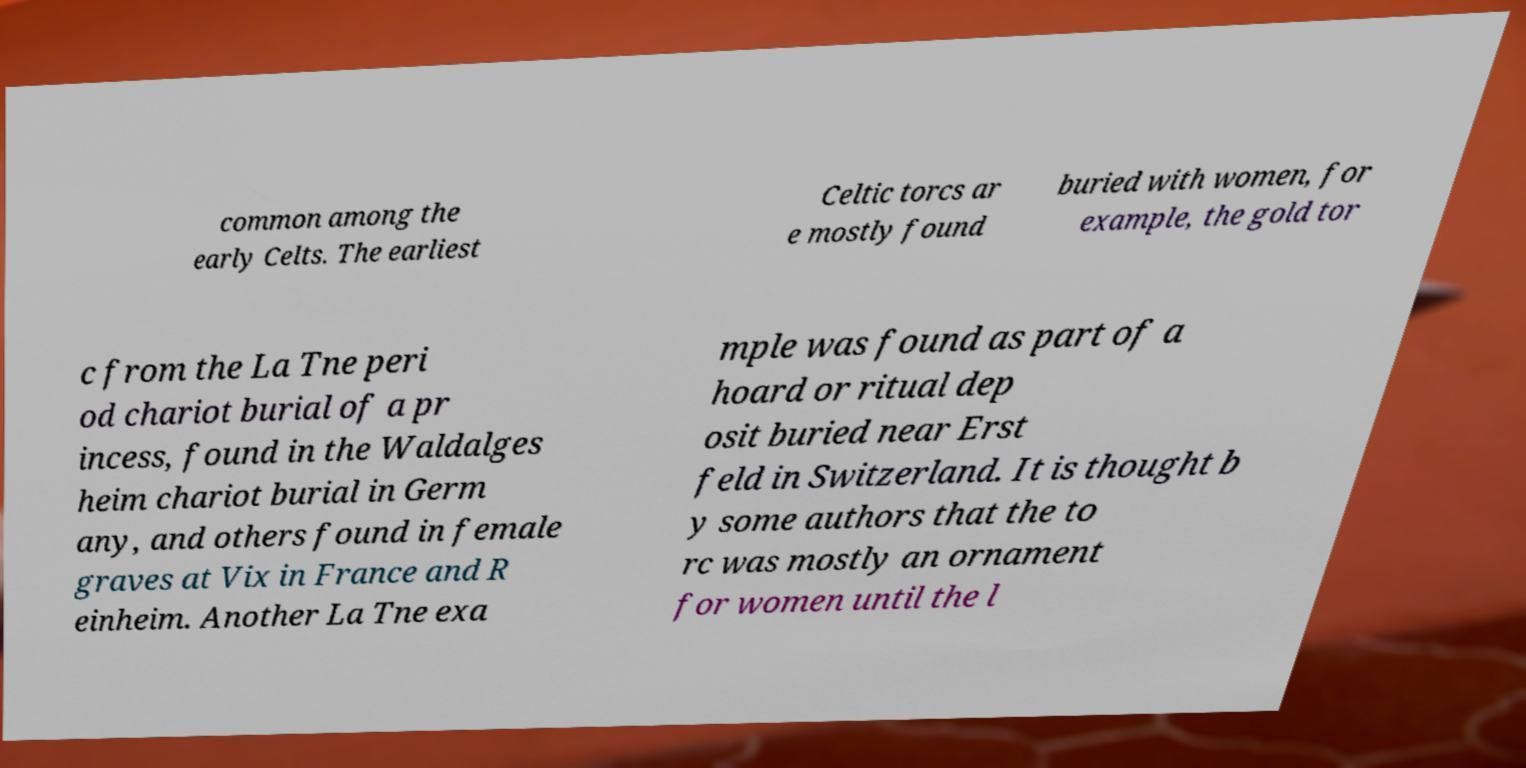Please read and relay the text visible in this image. What does it say? common among the early Celts. The earliest Celtic torcs ar e mostly found buried with women, for example, the gold tor c from the La Tne peri od chariot burial of a pr incess, found in the Waldalges heim chariot burial in Germ any, and others found in female graves at Vix in France and R einheim. Another La Tne exa mple was found as part of a hoard or ritual dep osit buried near Erst feld in Switzerland. It is thought b y some authors that the to rc was mostly an ornament for women until the l 